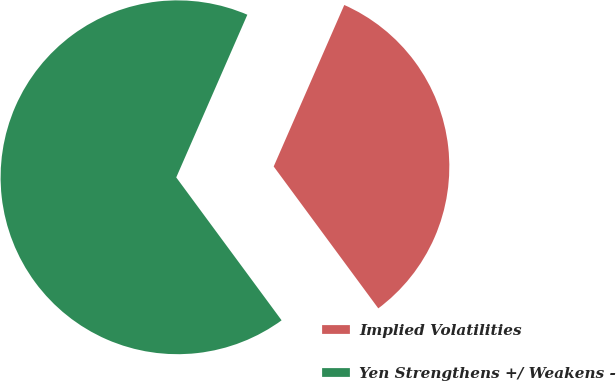Convert chart. <chart><loc_0><loc_0><loc_500><loc_500><pie_chart><fcel>Implied Volatilities<fcel>Yen Strengthens +/ Weakens -<nl><fcel>33.33%<fcel>66.67%<nl></chart> 